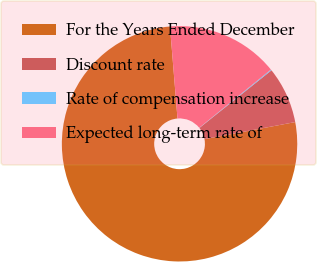Convert chart. <chart><loc_0><loc_0><loc_500><loc_500><pie_chart><fcel>For the Years Ended December<fcel>Discount rate<fcel>Rate of compensation increase<fcel>Expected long-term rate of<nl><fcel>76.66%<fcel>7.78%<fcel>0.13%<fcel>15.43%<nl></chart> 